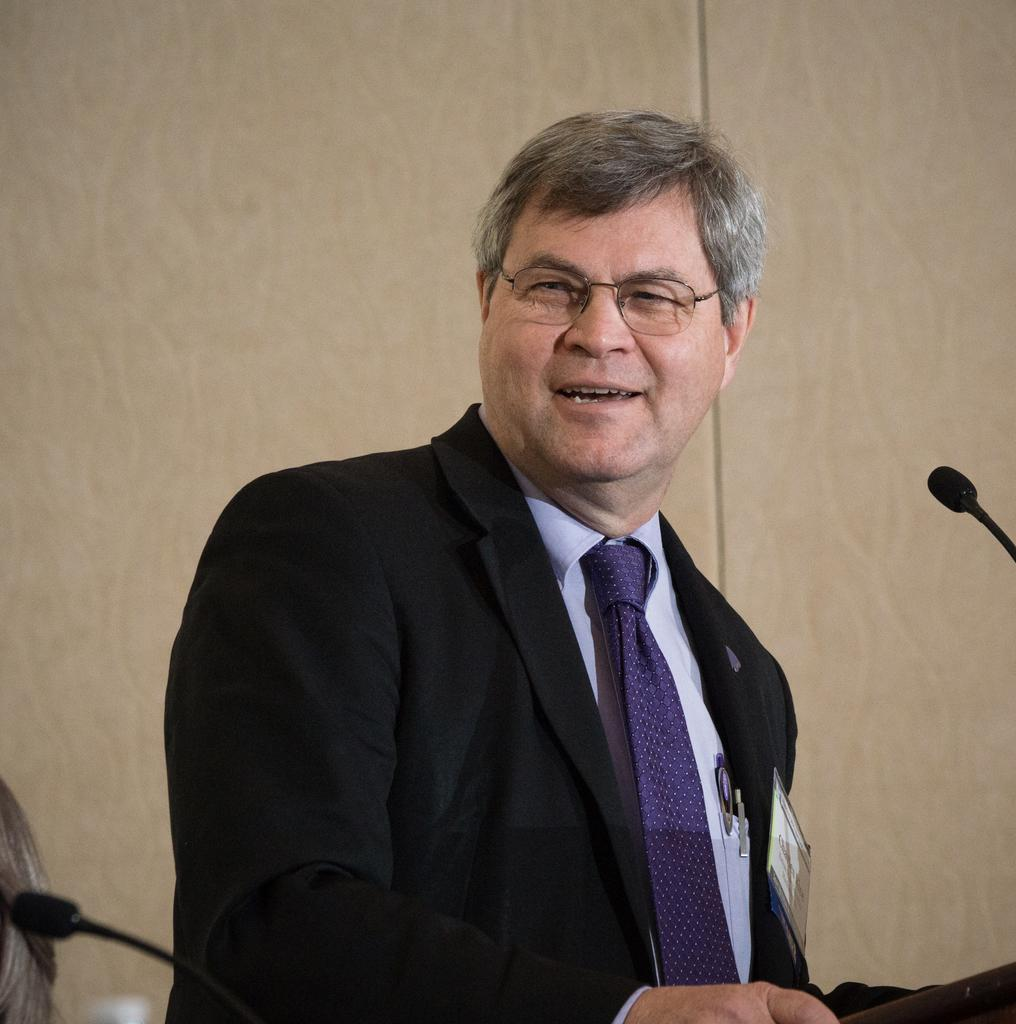What is the main subject of the image? There is a person in the image. What is the person wearing on their upper body? The person is wearing a black blazer. What type of accessory is the person wearing around their neck? The person is wearing a purple tie. What object is in front of the person? There is a microphone in front of the person. What color is the background wall in the image? The background wall is cream-colored. What flavor of geese can be seen in the image? There are no geese present in the image, so it is not possible to determine the flavor of any geese. 